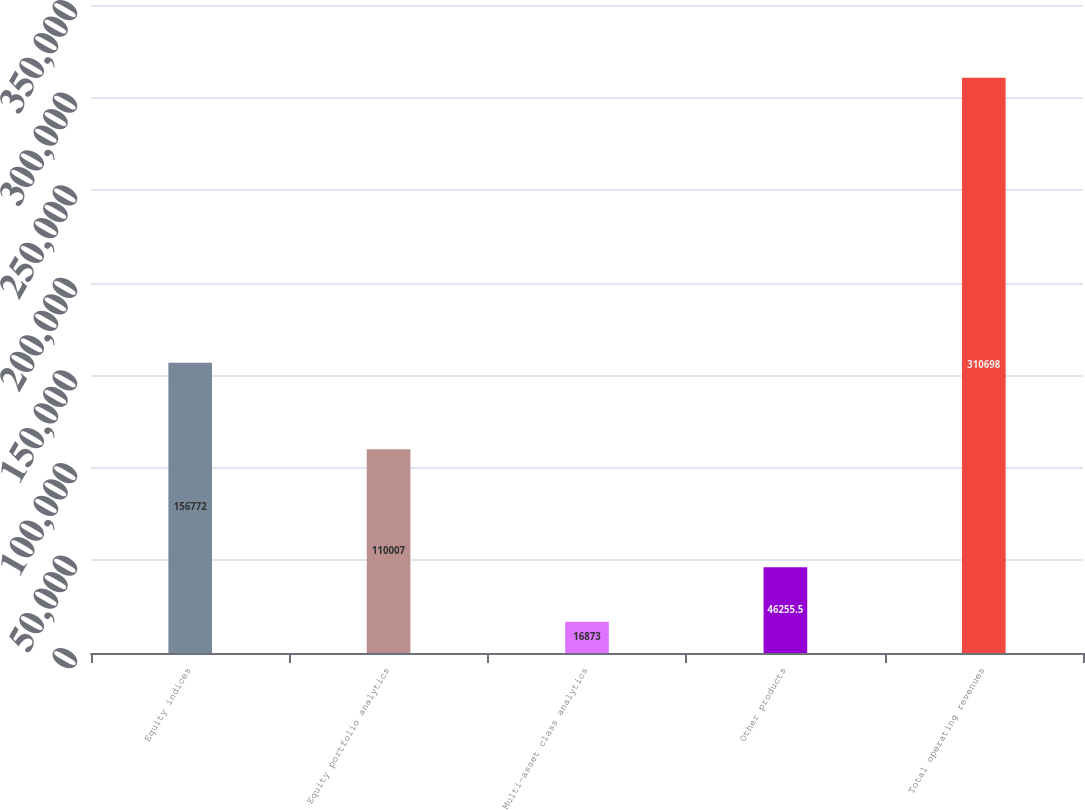<chart> <loc_0><loc_0><loc_500><loc_500><bar_chart><fcel>Equity indices<fcel>Equity portfolio analytics<fcel>Multi-asset class analytics<fcel>Other products<fcel>Total operating revenues<nl><fcel>156772<fcel>110007<fcel>16873<fcel>46255.5<fcel>310698<nl></chart> 